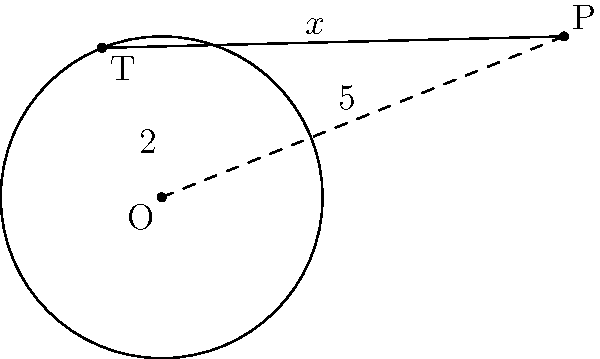In the diagram, O is the center of the circle with radius 2 units. Point P is 5 units away from O. If PT is tangent to the circle at point T, find the length of PT. Let's approach this step-by-step:

1) In a right-angled triangle, we can use the Pythagorean theorem. Here, triangle POT is right-angled because a tangent line is perpendicular to the radius at the point of tangency.

2) Let the length of PT be $x$ units. We know:
   - OT = 2 (radius of the circle)
   - OP = 5 (given in the question)

3) Applying the Pythagorean theorem to triangle POT:
   $$ OP^2 = OT^2 + PT^2 $$

4) Substituting the known values:
   $$ 5^2 = 2^2 + x^2 $$

5) Simplifying:
   $$ 25 = 4 + x^2 $$

6) Subtracting 4 from both sides:
   $$ 21 = x^2 $$

7) Taking the square root of both sides:
   $$ x = \sqrt{21} $$

Therefore, the length of PT is $\sqrt{21}$ units.
Answer: $\sqrt{21}$ units 